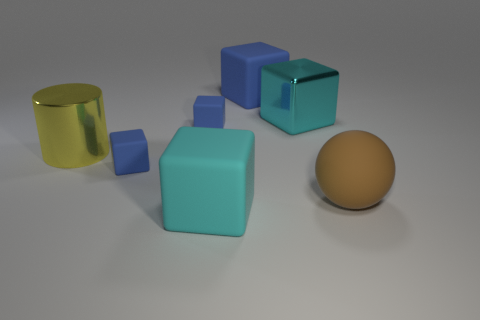How many other objects are the same material as the large brown object? Including the large brown object, there is a total of one object made of that matte textured material, which looks similar to a ceramic or plastic. No other objects share the same material; the others are metallic or have a different texture and sheen. 